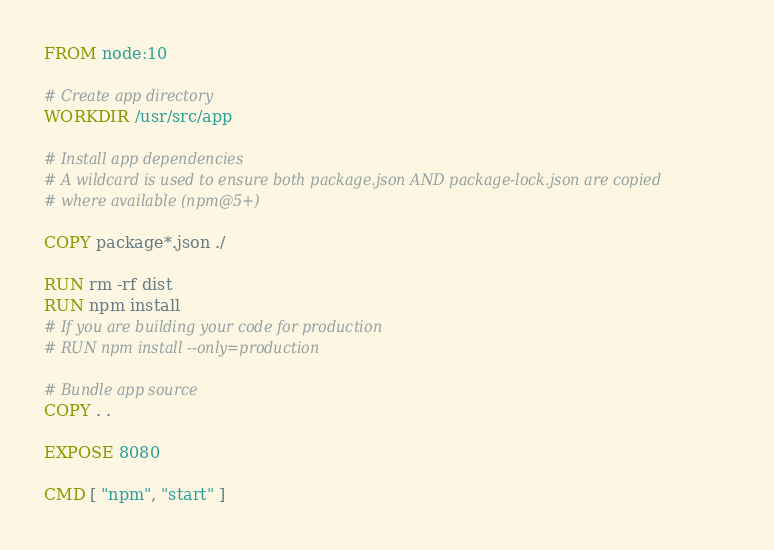<code> <loc_0><loc_0><loc_500><loc_500><_Dockerfile_>FROM node:10

# Create app directory
WORKDIR /usr/src/app

# Install app dependencies
# A wildcard is used to ensure both package.json AND package-lock.json are copied
# where available (npm@5+)

COPY package*.json ./

RUN rm -rf dist
RUN npm install
# If you are building your code for production
# RUN npm install --only=production

# Bundle app source
COPY . .

EXPOSE 8080

CMD [ "npm", "start" ]</code> 